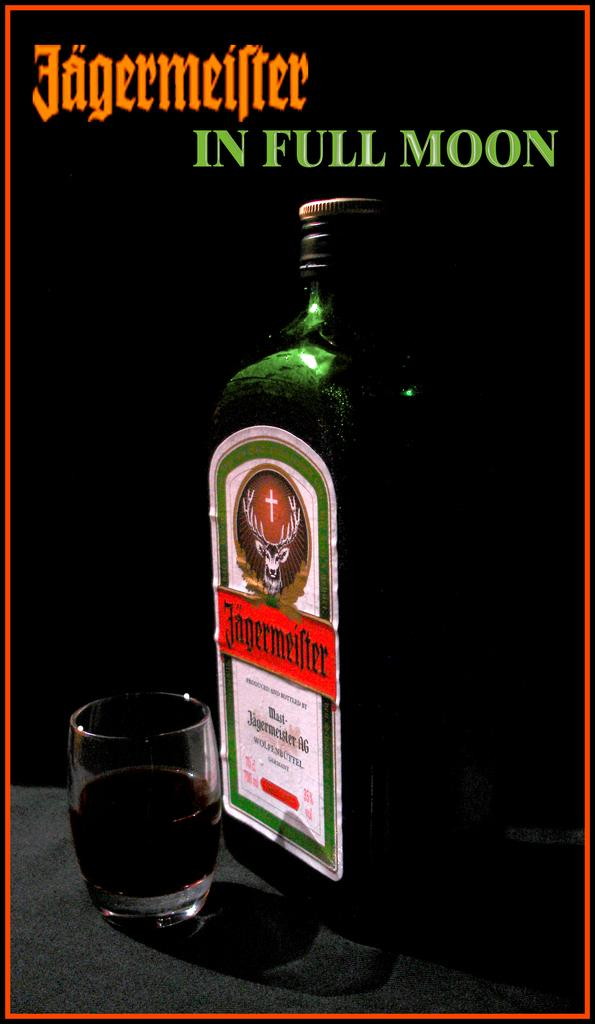<image>
Summarize the visual content of the image. Black background with Jagermeifter in orange and in full moon in green 